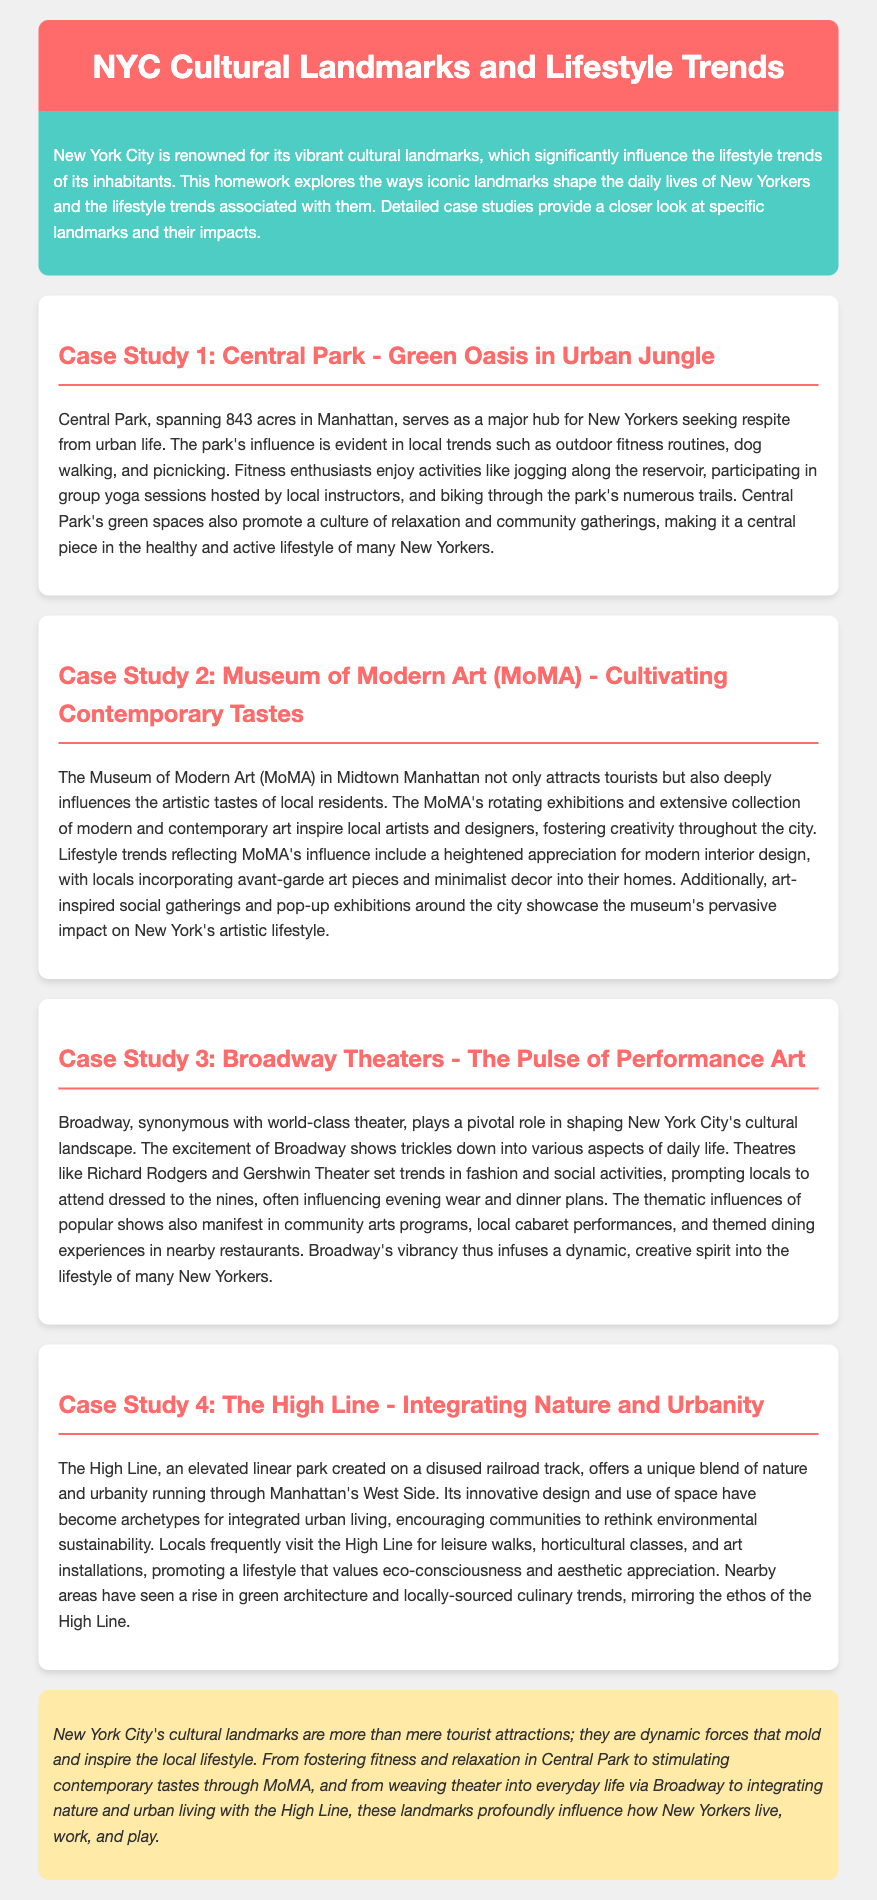What is the area of Central Park? Central Park spans 843 acres in Manhattan, as stated in the text.
Answer: 843 acres What is the main activity promoted by Central Park according to the document? The document highlights outdoor fitness routines, such as jogging and yoga, which are popular in Central Park.
Answer: Outdoor fitness routines Which museum is referred to for cultivating contemporary tastes? The document specifically mentions the Museum of Modern Art (MoMA) as influential in artistic tastes.
Answer: Museum of Modern Art (MoMA) What type of architectural trend has been inspired by the High Line? The document notes a rise in green architecture in areas near the High Line.
Answer: Green architecture How does Broadway influence local fashion? The document indicates that locals often attend Broadway shows dressed to the nines, influencing evening wear.
Answer: Influencing evening wear What common theme connects Central Park, MoMA, Broadway, and the High Line? Each landmark significantly influences local lifestyle trends, promoting various activities and aesthetics.
Answer: Influence on local lifestyle trends What color scheme is prominent in the document? The header and case study titles feature a consistent use of the color red, particularly #ff6b6b.
Answer: Red What type of gathering does Central Park promote? The park promotes community gatherings, as indicated in the analysis.
Answer: Community gatherings What does the case study on the High Line emphasize in terms of lifestyle? The High Line promotes a lifestyle valuing eco-consciousness and aesthetic appreciation, as stated in the text.
Answer: Eco-consciousness and aesthetic appreciation 